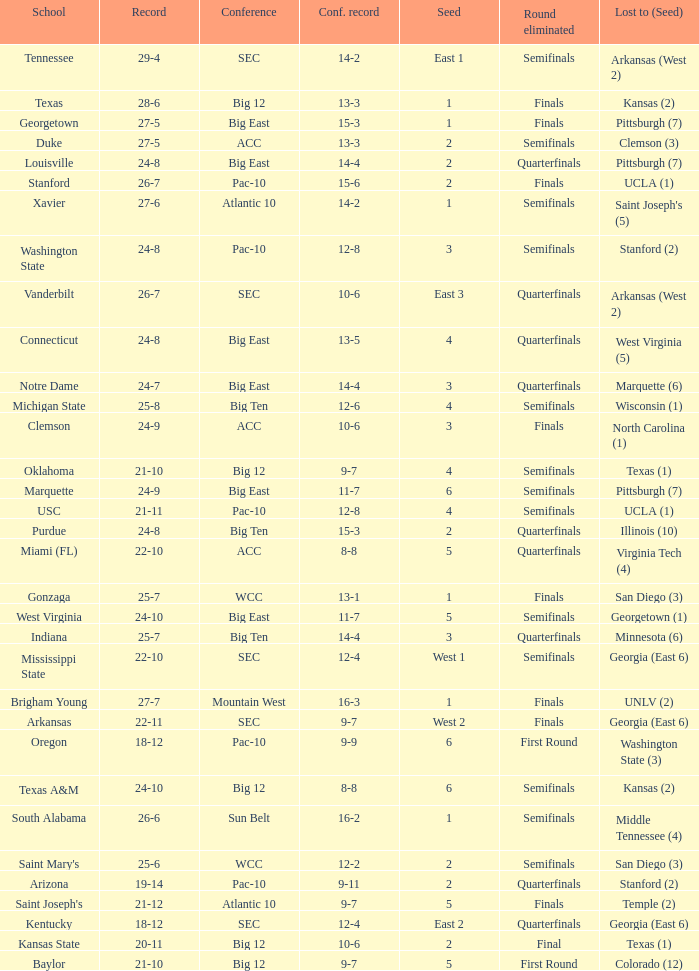Which school boasts a conference record of 12 wins and 6 losses? Michigan State. 